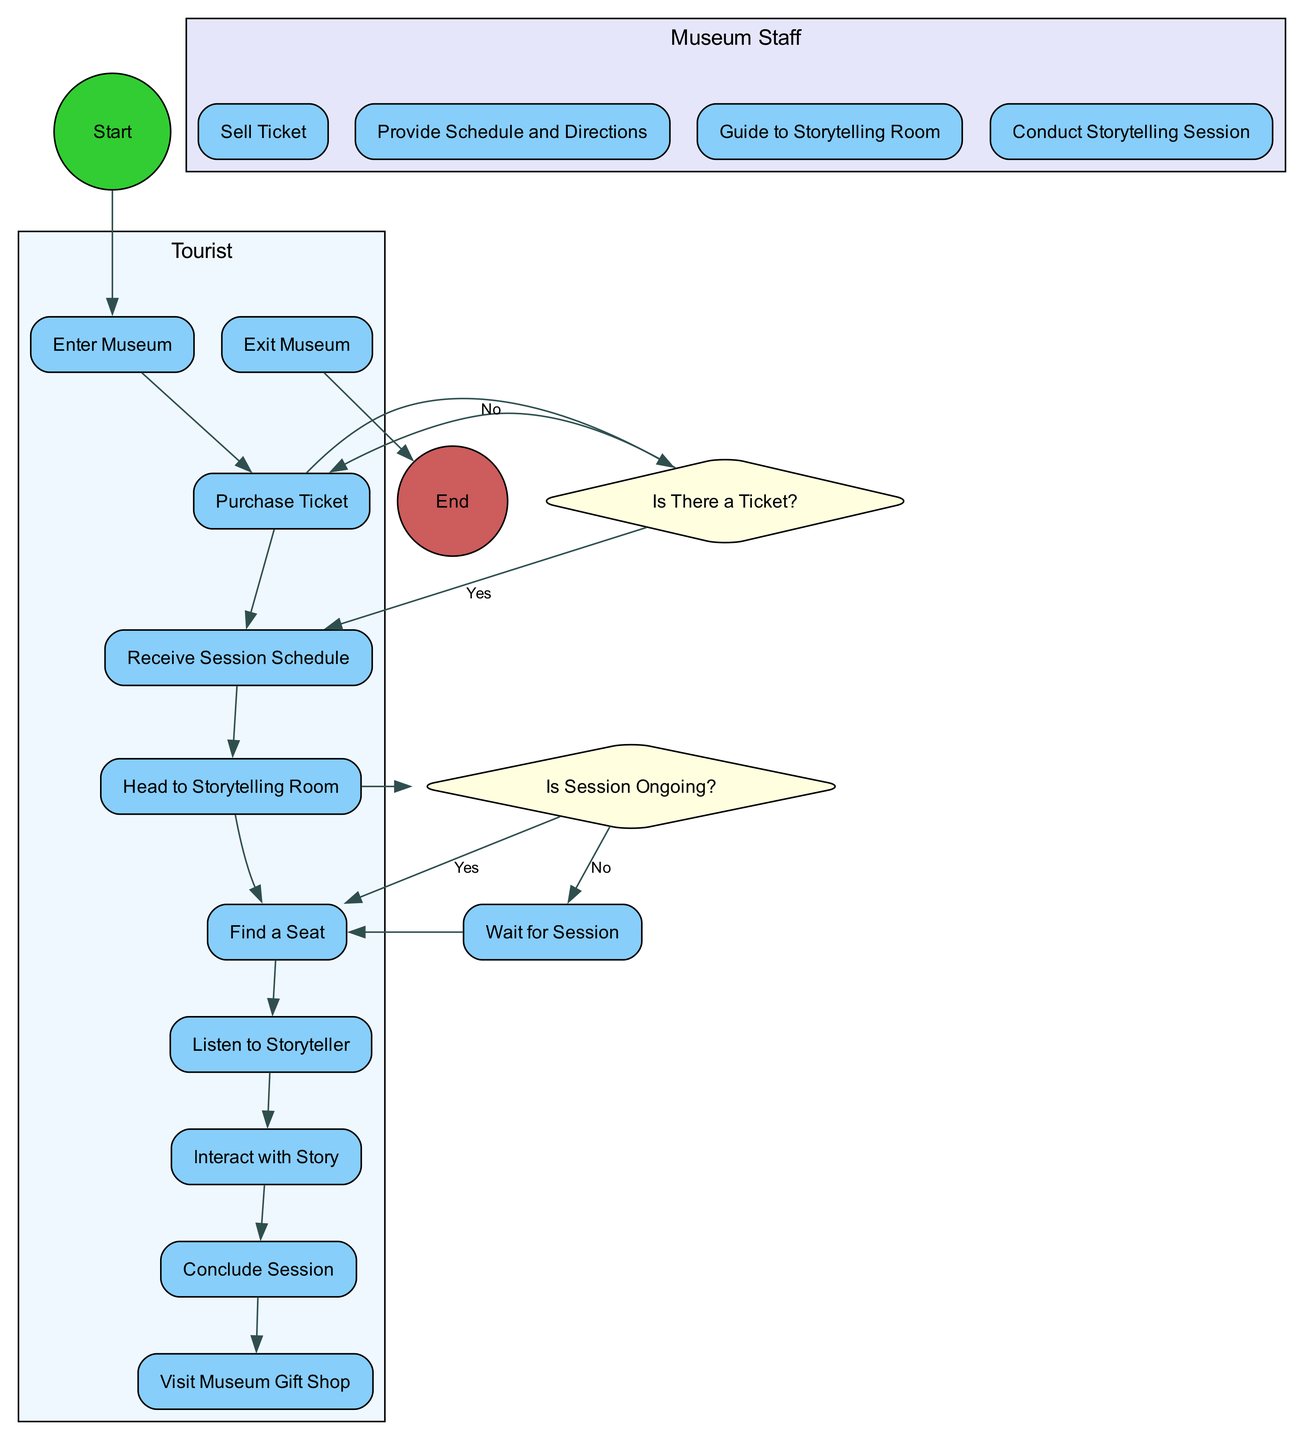What is the first activity shown in the diagram? The first activity in the diagram is "Enter Museum," which is the starting point for the tourist's journey. It is represented as the first node connected to the start node.
Answer: Enter Museum What activity follows "Purchase Ticket"? After "Purchase Ticket," the next activity is "Receive Session Schedule." This follows sequentially in the flow of the diagram, where purchasing the ticket leads to receiving additional information.
Answer: Receive Session Schedule How many activities are there in total? There are ten activities listed in the diagram. These activities are the various steps the tourist takes during the interactive storytelling session, including both actions by the tourist and the staff.
Answer: Ten What decision is made after "Purchase Ticket"? The decision made after "Purchase Ticket" is "Is There a Ticket?" This decision checks whether the tourist has already purchased a ticket or needs to do so.
Answer: Is There a Ticket? What happens if the tourist decides they do not have a ticket? If the tourist decides they do not have a ticket, they will return to "Purchase Ticket." This indicates that they must buy a ticket before proceeding with the session.
Answer: Purchase Ticket How many swimlanes are in the diagram? There are two swimlanes in the diagram, representing the distinct roles of the Tourist and Museum Staff. Each swimlane categorizes activities based on who is responsible for them.
Answer: Two Which activity directly leads to the decision "Is Session Ongoing?" The activity that leads directly to the decision "Is Session Ongoing?" is "Head to Storytelling Room." This indicates the tourist’s approach to the session before checking its status.
Answer: Head to Storytelling Room What is the last activity before exiting the museum? The last activity before exiting the museum is "Visit Museum Gift Shop." This activity allows the tourist to make a purchase before concluding the visit.
Answer: Visit Museum Gift Shop What activity is taken if the session is not ongoing? If the session is not ongoing, the tourist needs to "Wait for Session," indicating that they must wait until the session starts before finding a seat or beginning participation.
Answer: Wait for Session 